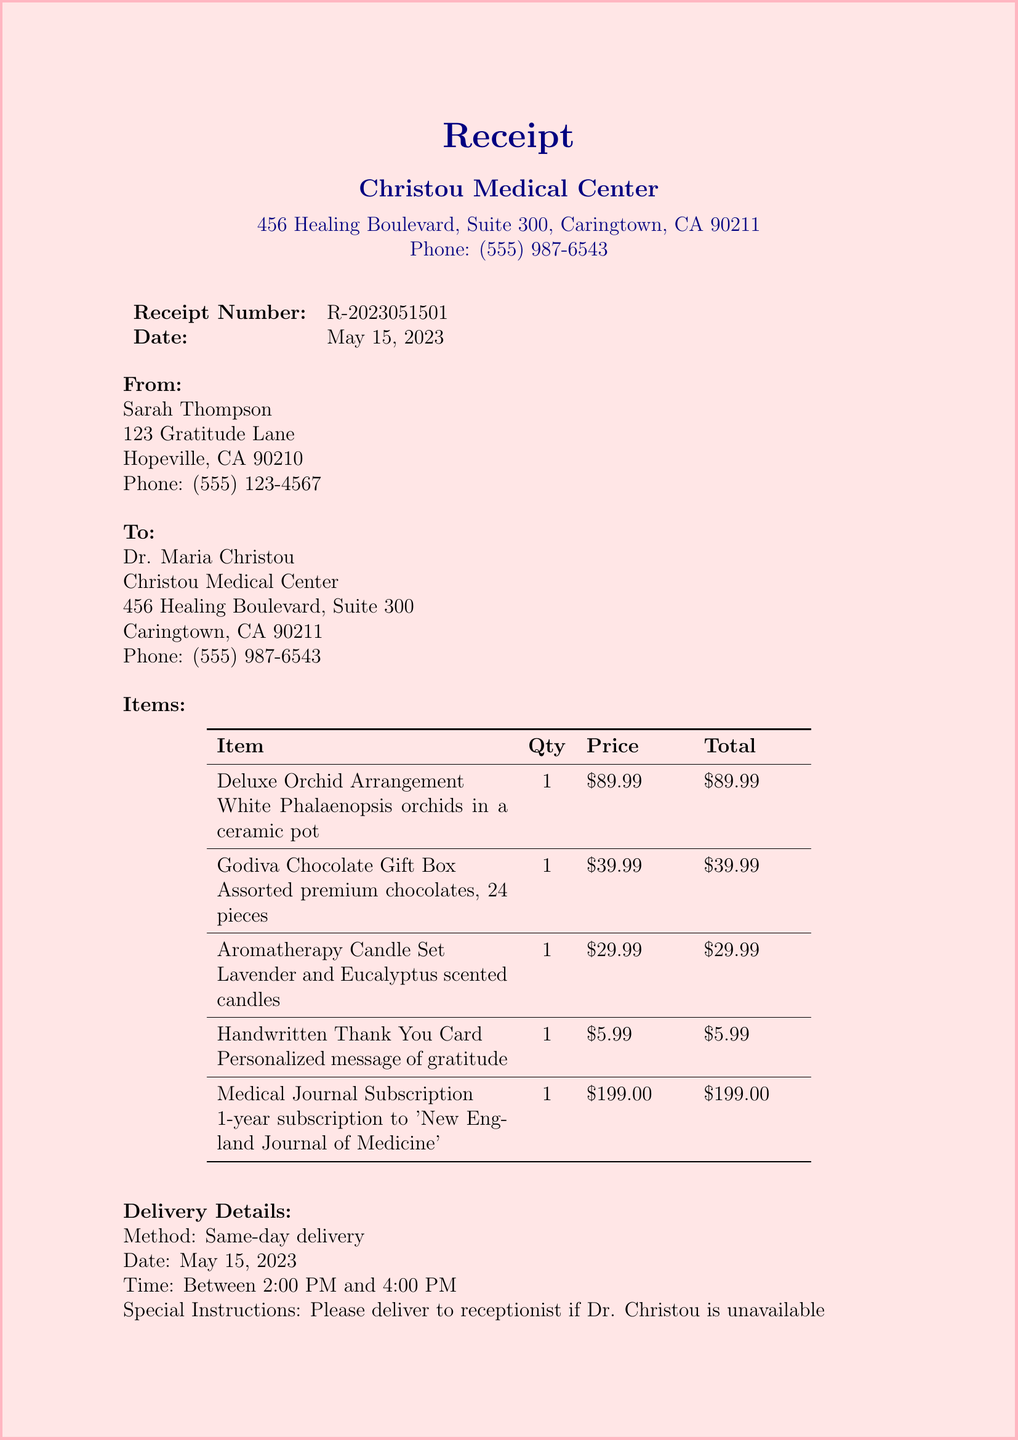What is the receipt number? The receipt number is listed at the top of the document as a unique identifier for this transaction.
Answer: R-2023051501 What is the total amount charged? The total amount charged is at the bottom of the document under the total section.
Answer: $425.71 Who is the sender of the flowers? The sender's name is mentioned in the "From" section of the document.
Answer: Sarah Thompson What is the date of delivery? The delivery date is specified in the delivery details section of the document.
Answer: May 15, 2023 What items were included in the care package? This requires referencing the items listed in the document.
Answer: Deluxe Orchid Arrangement, Godiva Chocolate Gift Box, Aromatherapy Candle Set, Handwritten Thank You Card, Medical Journal Subscription Why was the care package sent to Dr. Christou? The reason for sending the care package can be inferred from the message included in the document.
Answer: To express gratitude for expertise and compassion What delivery method was used? The delivery method is stated in the delivery details section of the document.
Answer: Same-day delivery What time frame was the delivery scheduled for? The document specifies the time during which delivery was to take place.
Answer: Between 2:00 PM and 4:00 PM What payment method was used for this purchase? The payment method is mentioned towards the end of the document.
Answer: Credit Card (Visa ending in 1234) 